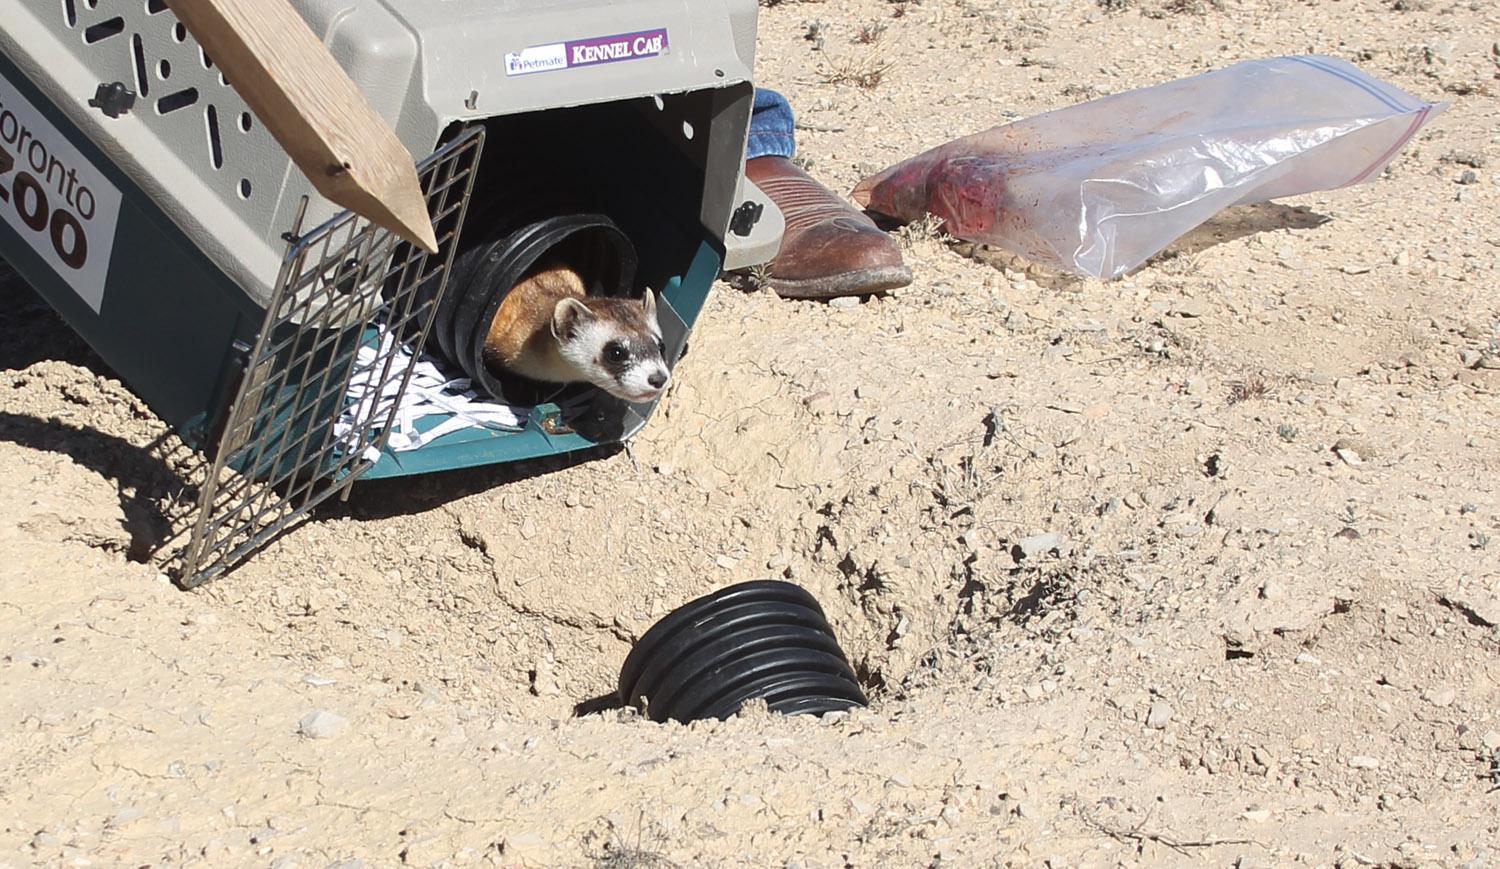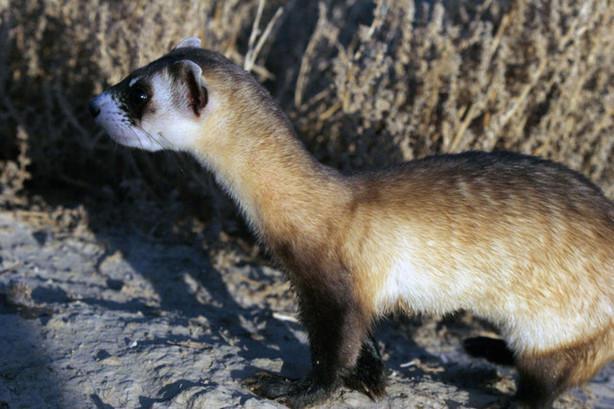The first image is the image on the left, the second image is the image on the right. Analyze the images presented: Is the assertion "There are exactly two ferrets with heads facing directly at the camera." valid? Answer yes or no. No. The first image is the image on the left, the second image is the image on the right. Examine the images to the left and right. Is the description "Each image shows a single ferret, and each ferrret is standing on all fours and looking toward the camera." accurate? Answer yes or no. No. 